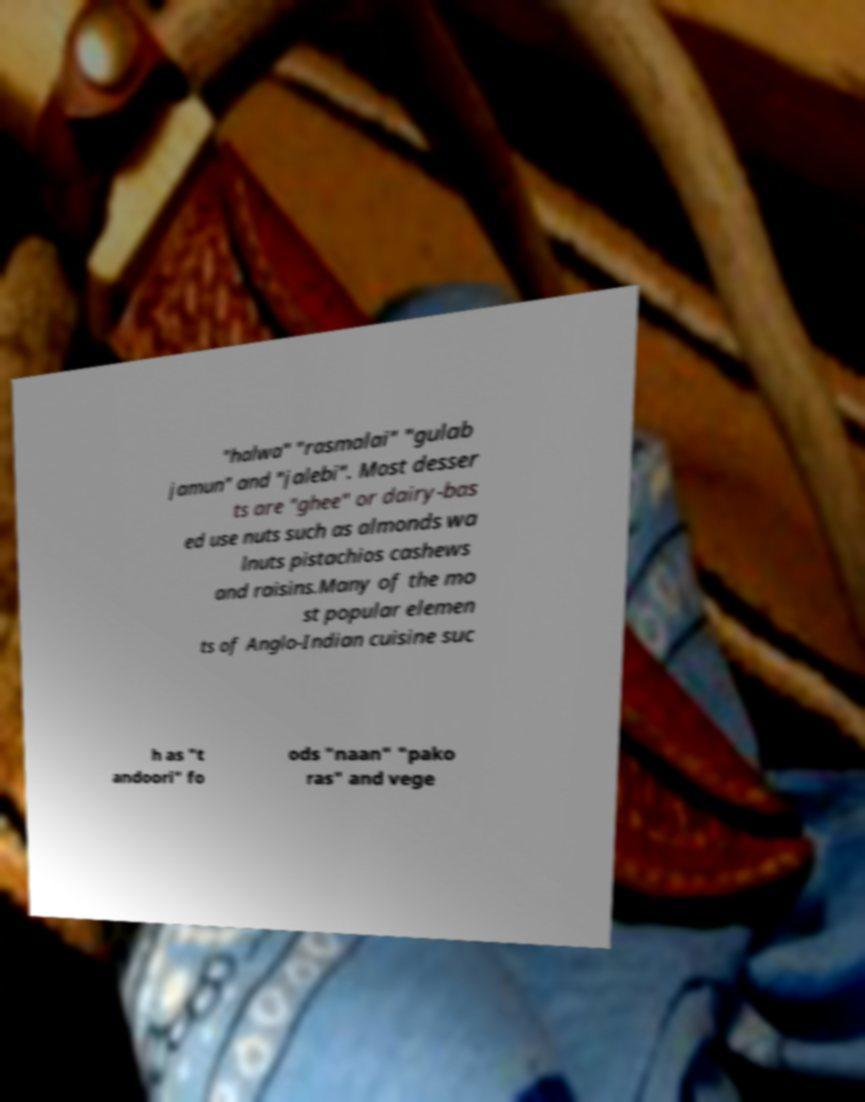What messages or text are displayed in this image? I need them in a readable, typed format. "halwa" "rasmalai" "gulab jamun" and "jalebi". Most desser ts are "ghee" or dairy-bas ed use nuts such as almonds wa lnuts pistachios cashews and raisins.Many of the mo st popular elemen ts of Anglo-Indian cuisine suc h as "t andoori" fo ods "naan" "pako ras" and vege 